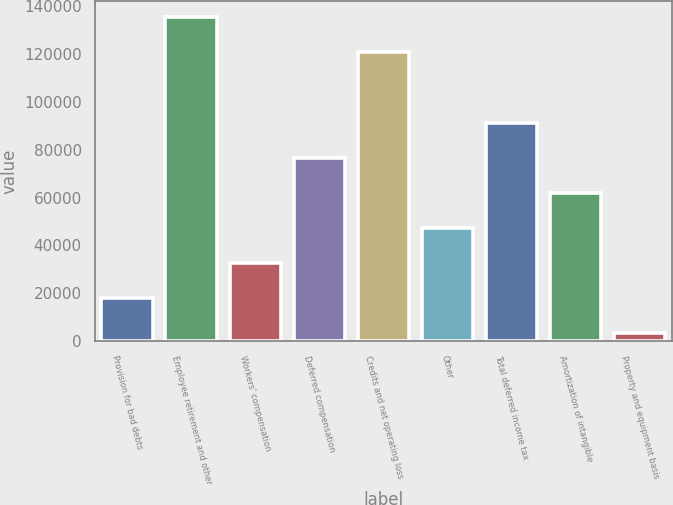Convert chart. <chart><loc_0><loc_0><loc_500><loc_500><bar_chart><fcel>Provision for bad debts<fcel>Employee retirement and other<fcel>Workers' compensation<fcel>Deferred compensation<fcel>Credits and net operating loss<fcel>Other<fcel>Total deferred income tax<fcel>Amortization of intangible<fcel>Property and equipment basis<nl><fcel>17892.1<fcel>135405<fcel>32581.2<fcel>76648.5<fcel>120716<fcel>47270.3<fcel>91337.6<fcel>61959.4<fcel>3203<nl></chart> 